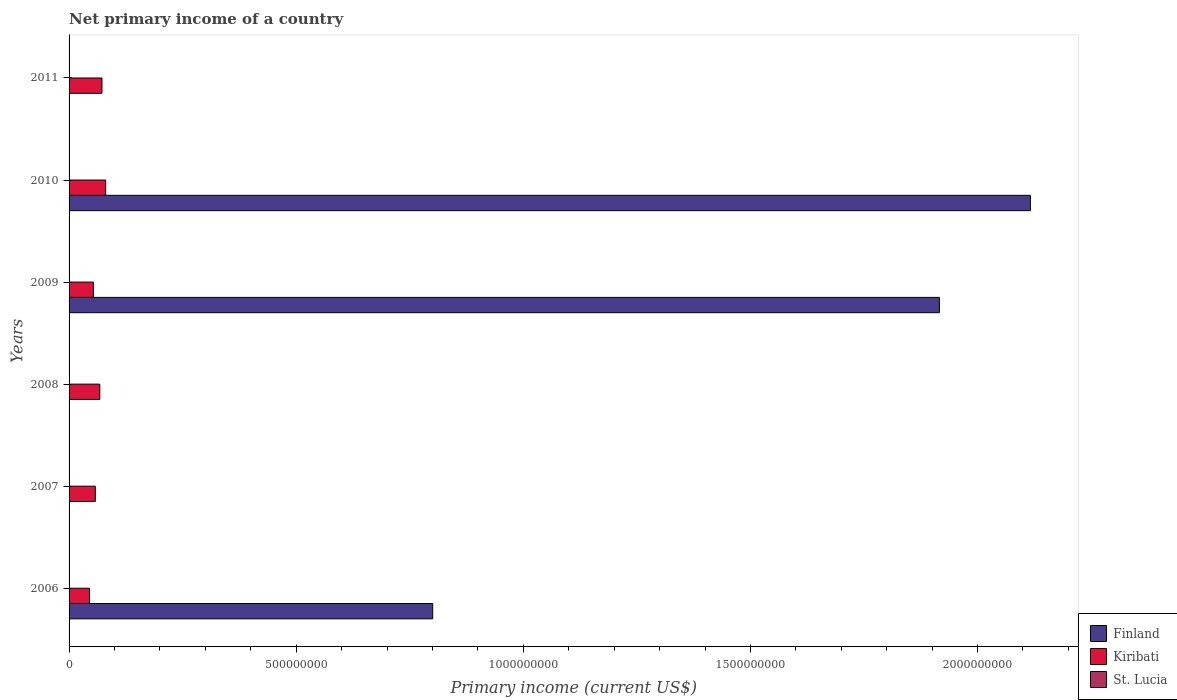How many different coloured bars are there?
Keep it short and to the point. 2. Are the number of bars per tick equal to the number of legend labels?
Give a very brief answer. No. Are the number of bars on each tick of the Y-axis equal?
Provide a short and direct response. No. How many bars are there on the 5th tick from the top?
Ensure brevity in your answer.  1. What is the label of the 6th group of bars from the top?
Provide a short and direct response. 2006. In how many cases, is the number of bars for a given year not equal to the number of legend labels?
Keep it short and to the point. 6. What is the primary income in Kiribati in 2007?
Your answer should be very brief. 5.78e+07. Across all years, what is the maximum primary income in Finland?
Provide a short and direct response. 2.12e+09. Across all years, what is the minimum primary income in Kiribati?
Give a very brief answer. 4.49e+07. In which year was the primary income in Finland maximum?
Your response must be concise. 2010. What is the total primary income in Kiribati in the graph?
Keep it short and to the point. 3.77e+08. What is the difference between the primary income in Kiribati in 2006 and that in 2009?
Your answer should be very brief. -8.59e+06. What is the difference between the primary income in St. Lucia in 2006 and the primary income in Kiribati in 2009?
Your answer should be very brief. -5.35e+07. What is the average primary income in Finland per year?
Provide a succinct answer. 8.05e+08. In the year 2010, what is the difference between the primary income in Finland and primary income in Kiribati?
Your response must be concise. 2.04e+09. In how many years, is the primary income in Kiribati greater than 1600000000 US$?
Ensure brevity in your answer.  0. What is the ratio of the primary income in Kiribati in 2007 to that in 2008?
Make the answer very short. 0.85. Is the difference between the primary income in Finland in 2009 and 2010 greater than the difference between the primary income in Kiribati in 2009 and 2010?
Ensure brevity in your answer.  No. What is the difference between the highest and the second highest primary income in Kiribati?
Give a very brief answer. 8.13e+06. What is the difference between the highest and the lowest primary income in Kiribati?
Your answer should be very brief. 3.56e+07. Is the sum of the primary income in Kiribati in 2006 and 2010 greater than the maximum primary income in Finland across all years?
Keep it short and to the point. No. Is it the case that in every year, the sum of the primary income in Finland and primary income in Kiribati is greater than the primary income in St. Lucia?
Offer a terse response. Yes. How many bars are there?
Your response must be concise. 9. Are all the bars in the graph horizontal?
Your response must be concise. Yes. What is the difference between two consecutive major ticks on the X-axis?
Your response must be concise. 5.00e+08. Are the values on the major ticks of X-axis written in scientific E-notation?
Your answer should be compact. No. Does the graph contain any zero values?
Your response must be concise. Yes. Where does the legend appear in the graph?
Keep it short and to the point. Bottom right. What is the title of the graph?
Offer a very short reply. Net primary income of a country. What is the label or title of the X-axis?
Offer a very short reply. Primary income (current US$). What is the Primary income (current US$) in Finland in 2006?
Provide a succinct answer. 8.01e+08. What is the Primary income (current US$) of Kiribati in 2006?
Ensure brevity in your answer.  4.49e+07. What is the Primary income (current US$) of Finland in 2007?
Your response must be concise. 0. What is the Primary income (current US$) of Kiribati in 2007?
Make the answer very short. 5.78e+07. What is the Primary income (current US$) in St. Lucia in 2007?
Provide a succinct answer. 0. What is the Primary income (current US$) of Finland in 2008?
Provide a succinct answer. 0. What is the Primary income (current US$) of Kiribati in 2008?
Provide a succinct answer. 6.76e+07. What is the Primary income (current US$) in St. Lucia in 2008?
Offer a terse response. 0. What is the Primary income (current US$) in Finland in 2009?
Offer a terse response. 1.92e+09. What is the Primary income (current US$) of Kiribati in 2009?
Provide a short and direct response. 5.35e+07. What is the Primary income (current US$) in Finland in 2010?
Ensure brevity in your answer.  2.12e+09. What is the Primary income (current US$) in Kiribati in 2010?
Give a very brief answer. 8.05e+07. What is the Primary income (current US$) of Kiribati in 2011?
Your answer should be very brief. 7.24e+07. What is the Primary income (current US$) of St. Lucia in 2011?
Keep it short and to the point. 0. Across all years, what is the maximum Primary income (current US$) in Finland?
Give a very brief answer. 2.12e+09. Across all years, what is the maximum Primary income (current US$) in Kiribati?
Offer a very short reply. 8.05e+07. Across all years, what is the minimum Primary income (current US$) of Finland?
Ensure brevity in your answer.  0. Across all years, what is the minimum Primary income (current US$) of Kiribati?
Ensure brevity in your answer.  4.49e+07. What is the total Primary income (current US$) of Finland in the graph?
Your response must be concise. 4.83e+09. What is the total Primary income (current US$) of Kiribati in the graph?
Your answer should be very brief. 3.77e+08. What is the total Primary income (current US$) in St. Lucia in the graph?
Ensure brevity in your answer.  0. What is the difference between the Primary income (current US$) in Kiribati in 2006 and that in 2007?
Keep it short and to the point. -1.29e+07. What is the difference between the Primary income (current US$) of Kiribati in 2006 and that in 2008?
Your response must be concise. -2.27e+07. What is the difference between the Primary income (current US$) in Finland in 2006 and that in 2009?
Offer a very short reply. -1.12e+09. What is the difference between the Primary income (current US$) of Kiribati in 2006 and that in 2009?
Keep it short and to the point. -8.59e+06. What is the difference between the Primary income (current US$) in Finland in 2006 and that in 2010?
Your response must be concise. -1.32e+09. What is the difference between the Primary income (current US$) in Kiribati in 2006 and that in 2010?
Your response must be concise. -3.56e+07. What is the difference between the Primary income (current US$) of Kiribati in 2006 and that in 2011?
Provide a succinct answer. -2.75e+07. What is the difference between the Primary income (current US$) of Kiribati in 2007 and that in 2008?
Keep it short and to the point. -9.83e+06. What is the difference between the Primary income (current US$) in Kiribati in 2007 and that in 2009?
Ensure brevity in your answer.  4.28e+06. What is the difference between the Primary income (current US$) of Kiribati in 2007 and that in 2010?
Offer a terse response. -2.28e+07. What is the difference between the Primary income (current US$) in Kiribati in 2007 and that in 2011?
Give a very brief answer. -1.46e+07. What is the difference between the Primary income (current US$) of Kiribati in 2008 and that in 2009?
Keep it short and to the point. 1.41e+07. What is the difference between the Primary income (current US$) in Kiribati in 2008 and that in 2010?
Offer a very short reply. -1.29e+07. What is the difference between the Primary income (current US$) in Kiribati in 2008 and that in 2011?
Keep it short and to the point. -4.80e+06. What is the difference between the Primary income (current US$) of Finland in 2009 and that in 2010?
Your answer should be very brief. -2.00e+08. What is the difference between the Primary income (current US$) of Kiribati in 2009 and that in 2010?
Ensure brevity in your answer.  -2.70e+07. What is the difference between the Primary income (current US$) of Kiribati in 2009 and that in 2011?
Provide a short and direct response. -1.89e+07. What is the difference between the Primary income (current US$) in Kiribati in 2010 and that in 2011?
Keep it short and to the point. 8.13e+06. What is the difference between the Primary income (current US$) in Finland in 2006 and the Primary income (current US$) in Kiribati in 2007?
Make the answer very short. 7.43e+08. What is the difference between the Primary income (current US$) of Finland in 2006 and the Primary income (current US$) of Kiribati in 2008?
Offer a terse response. 7.33e+08. What is the difference between the Primary income (current US$) of Finland in 2006 and the Primary income (current US$) of Kiribati in 2009?
Your answer should be very brief. 7.47e+08. What is the difference between the Primary income (current US$) in Finland in 2006 and the Primary income (current US$) in Kiribati in 2010?
Keep it short and to the point. 7.20e+08. What is the difference between the Primary income (current US$) of Finland in 2006 and the Primary income (current US$) of Kiribati in 2011?
Offer a terse response. 7.28e+08. What is the difference between the Primary income (current US$) in Finland in 2009 and the Primary income (current US$) in Kiribati in 2010?
Ensure brevity in your answer.  1.84e+09. What is the difference between the Primary income (current US$) in Finland in 2009 and the Primary income (current US$) in Kiribati in 2011?
Make the answer very short. 1.84e+09. What is the difference between the Primary income (current US$) in Finland in 2010 and the Primary income (current US$) in Kiribati in 2011?
Ensure brevity in your answer.  2.04e+09. What is the average Primary income (current US$) of Finland per year?
Provide a short and direct response. 8.05e+08. What is the average Primary income (current US$) of Kiribati per year?
Provide a short and direct response. 6.28e+07. What is the average Primary income (current US$) of St. Lucia per year?
Keep it short and to the point. 0. In the year 2006, what is the difference between the Primary income (current US$) of Finland and Primary income (current US$) of Kiribati?
Make the answer very short. 7.56e+08. In the year 2009, what is the difference between the Primary income (current US$) of Finland and Primary income (current US$) of Kiribati?
Your answer should be compact. 1.86e+09. In the year 2010, what is the difference between the Primary income (current US$) in Finland and Primary income (current US$) in Kiribati?
Offer a very short reply. 2.04e+09. What is the ratio of the Primary income (current US$) in Kiribati in 2006 to that in 2007?
Provide a succinct answer. 0.78. What is the ratio of the Primary income (current US$) of Kiribati in 2006 to that in 2008?
Ensure brevity in your answer.  0.66. What is the ratio of the Primary income (current US$) in Finland in 2006 to that in 2009?
Give a very brief answer. 0.42. What is the ratio of the Primary income (current US$) of Kiribati in 2006 to that in 2009?
Your response must be concise. 0.84. What is the ratio of the Primary income (current US$) of Finland in 2006 to that in 2010?
Your answer should be very brief. 0.38. What is the ratio of the Primary income (current US$) in Kiribati in 2006 to that in 2010?
Your response must be concise. 0.56. What is the ratio of the Primary income (current US$) in Kiribati in 2006 to that in 2011?
Give a very brief answer. 0.62. What is the ratio of the Primary income (current US$) of Kiribati in 2007 to that in 2008?
Keep it short and to the point. 0.85. What is the ratio of the Primary income (current US$) in Kiribati in 2007 to that in 2010?
Offer a very short reply. 0.72. What is the ratio of the Primary income (current US$) in Kiribati in 2007 to that in 2011?
Provide a succinct answer. 0.8. What is the ratio of the Primary income (current US$) of Kiribati in 2008 to that in 2009?
Ensure brevity in your answer.  1.26. What is the ratio of the Primary income (current US$) in Kiribati in 2008 to that in 2010?
Provide a short and direct response. 0.84. What is the ratio of the Primary income (current US$) of Kiribati in 2008 to that in 2011?
Your response must be concise. 0.93. What is the ratio of the Primary income (current US$) of Finland in 2009 to that in 2010?
Ensure brevity in your answer.  0.91. What is the ratio of the Primary income (current US$) in Kiribati in 2009 to that in 2010?
Ensure brevity in your answer.  0.66. What is the ratio of the Primary income (current US$) in Kiribati in 2009 to that in 2011?
Your response must be concise. 0.74. What is the ratio of the Primary income (current US$) in Kiribati in 2010 to that in 2011?
Your response must be concise. 1.11. What is the difference between the highest and the second highest Primary income (current US$) in Finland?
Provide a short and direct response. 2.00e+08. What is the difference between the highest and the second highest Primary income (current US$) of Kiribati?
Ensure brevity in your answer.  8.13e+06. What is the difference between the highest and the lowest Primary income (current US$) of Finland?
Offer a terse response. 2.12e+09. What is the difference between the highest and the lowest Primary income (current US$) in Kiribati?
Make the answer very short. 3.56e+07. 